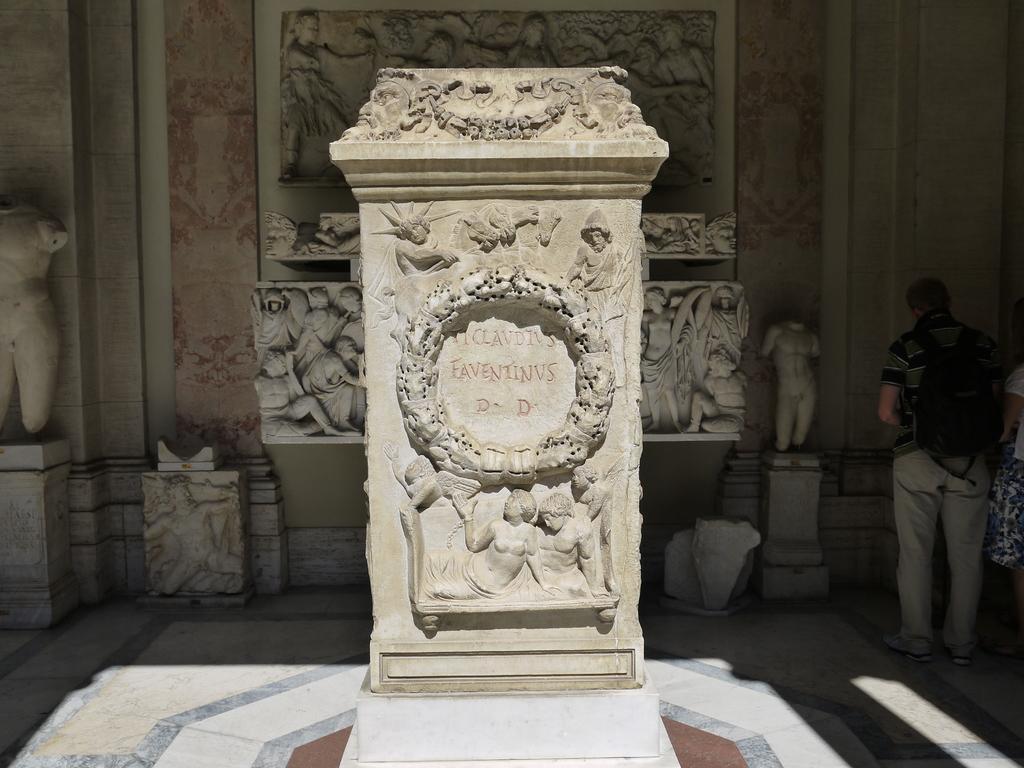Please provide a concise description of this image. In this picture I can observe a stone in the middle of the picture. There are some carvings on the stone. On the right side I can observe a person standing on the floor. In the background I can observe a wall and there are some carvings on the wall. 